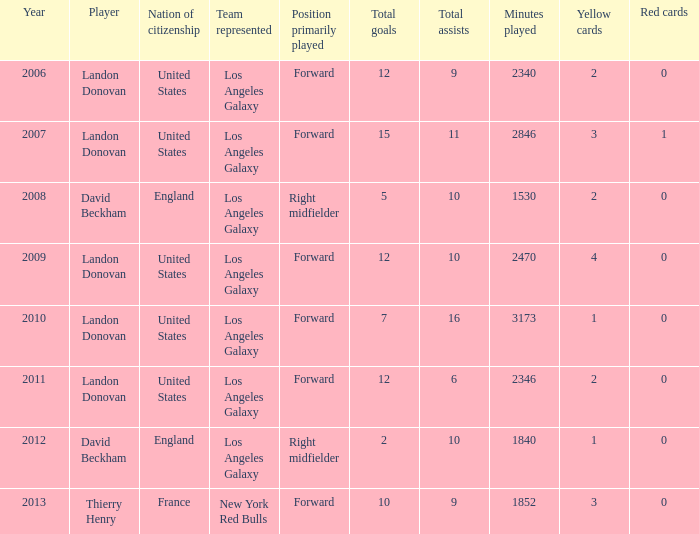What is the sum of all the years that Landon Donovan won the ESPY award? 5.0. 